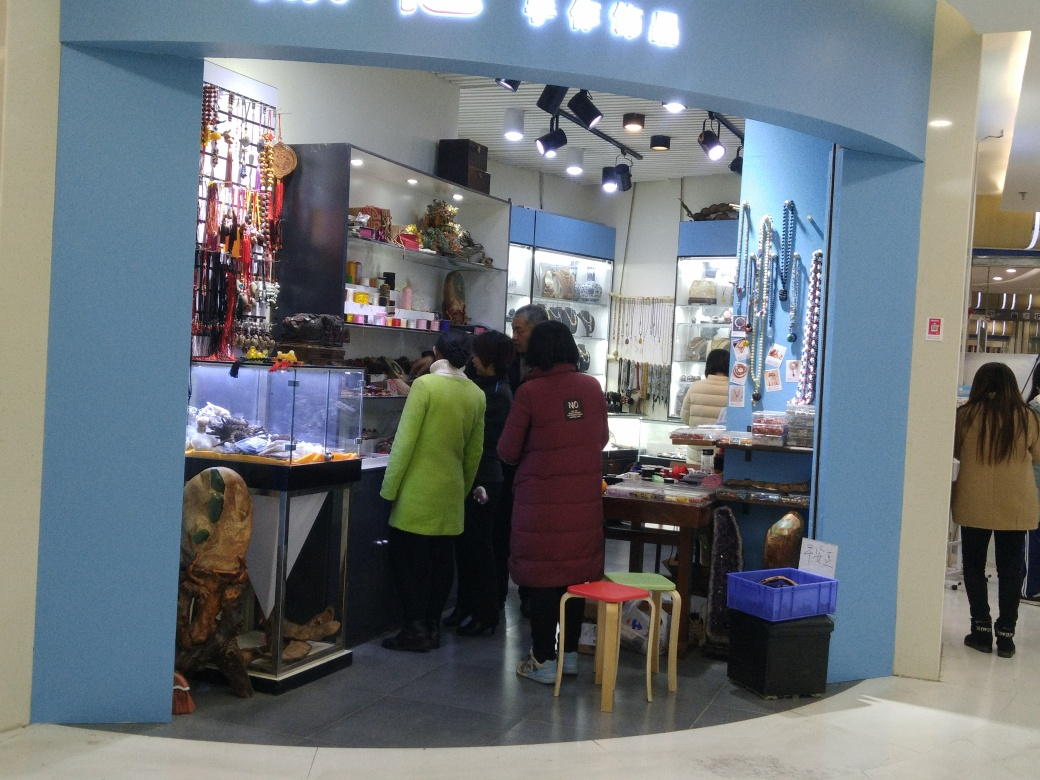How might the design of the shop influence customer behavior? The open design of the shop, with no visible door barriers and items displayed close to the aisle, invites passers-by to casually gaze at the merchandise and may encourage spontaneous purchases. The setup seems welcoming and accessible, creating an environment of easy engagement with the products. 